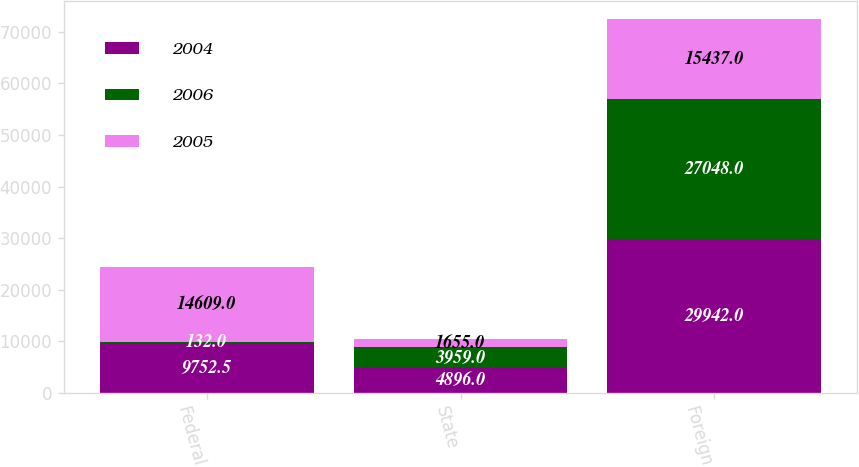Convert chart to OTSL. <chart><loc_0><loc_0><loc_500><loc_500><stacked_bar_chart><ecel><fcel>Federal<fcel>State<fcel>Foreign<nl><fcel>2004<fcel>9752.5<fcel>4896<fcel>29942<nl><fcel>2006<fcel>132<fcel>3959<fcel>27048<nl><fcel>2005<fcel>14609<fcel>1655<fcel>15437<nl></chart> 